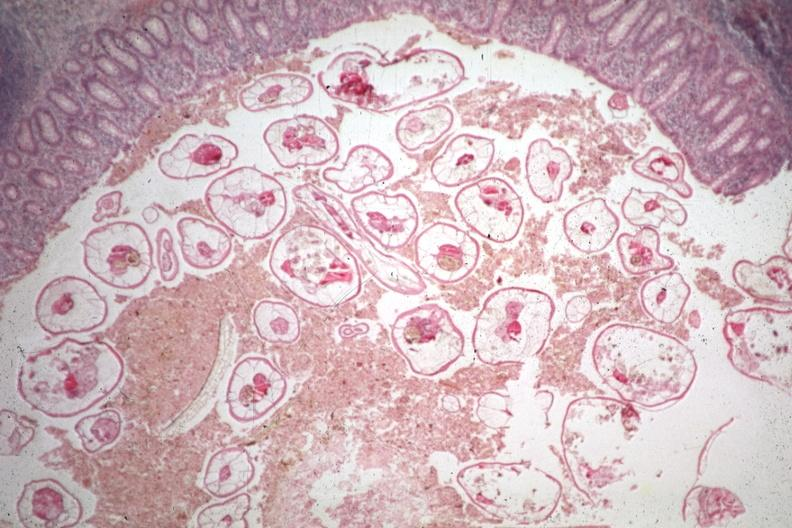s appendix present?
Answer the question using a single word or phrase. Yes 